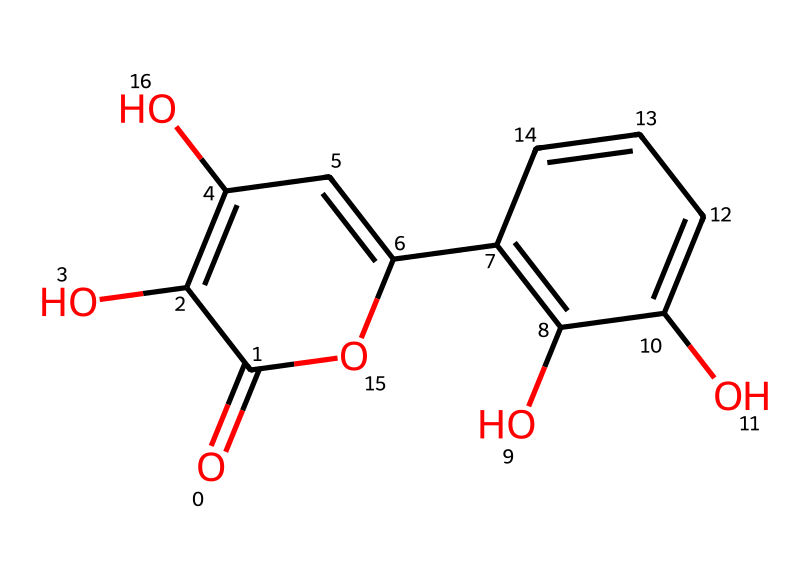What is the name of this chemical? The chemical depicted in the provided SMILES is quercetin, which is a flavonoid present in many plants and is known for its antioxidant properties.
Answer: quercetin How many hydroxyl groups are present in the structure? By examining the structure, we can identify the hydroxyl (–OH) groups. There are three places in the structure where hydroxyl groups are connected to carbon atoms.
Answer: three What is the total number of carbon atoms in quercetin? By counting the carbon atoms present in the structure based on the number of carbon entities in the SMILES representation, we find that there are 15 carbon atoms.
Answer: 15 Does this compound contain any double bonds? The structure reveals multiple double bonds in the form of aromatic rings and functional groups, confirmed by the presence of the "=" symbol in the SMILES representation.
Answer: yes Which part of quercetin contributes to its antioxidant properties? Quercetin contains multiple hydroxyl groups and a conjugated system of double bonds that enhance its ability to scavenge free radicals, evidenced by the presence of the hydroxyl groups and the aromatic rings in the structure.
Answer: hydroxyl groups What type of chemical is quercetin classified as? Quercetin is classified as a flavonoid, which is a specific type of polyphenolic compound characterized by a common three-ring structure with hydroxyl substitutions, as seen in the overall structure of the molecule.
Answer: flavonoid Is quercetin soluble in water? Quercetin is generally soluble in water due to its hydroxyl groups, which can form hydrogen bonds with water molecules, a property that is typical of phenolic compounds.
Answer: yes 